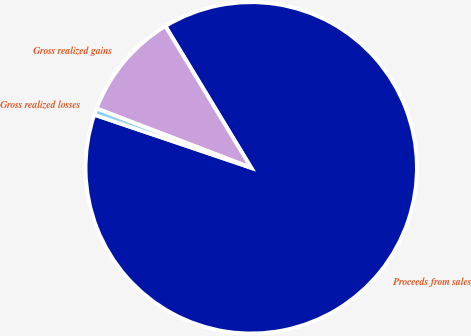<chart> <loc_0><loc_0><loc_500><loc_500><pie_chart><fcel>Proceeds from sales<fcel>Gross realized gains<fcel>Gross realized losses<nl><fcel>88.86%<fcel>10.5%<fcel>0.64%<nl></chart> 